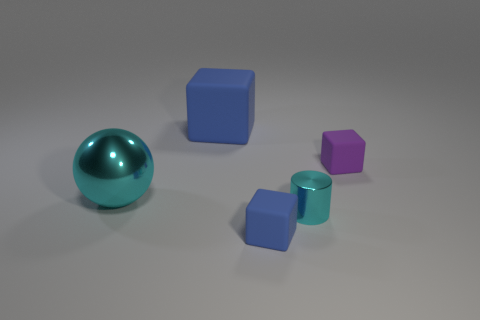Add 3 small blue metallic cylinders. How many objects exist? 8 Subtract all spheres. How many objects are left? 4 Add 5 big cyan metallic balls. How many big cyan metallic balls exist? 6 Subtract 0 brown cylinders. How many objects are left? 5 Subtract all big blue matte cylinders. Subtract all tiny shiny objects. How many objects are left? 4 Add 5 tiny matte objects. How many tiny matte objects are left? 7 